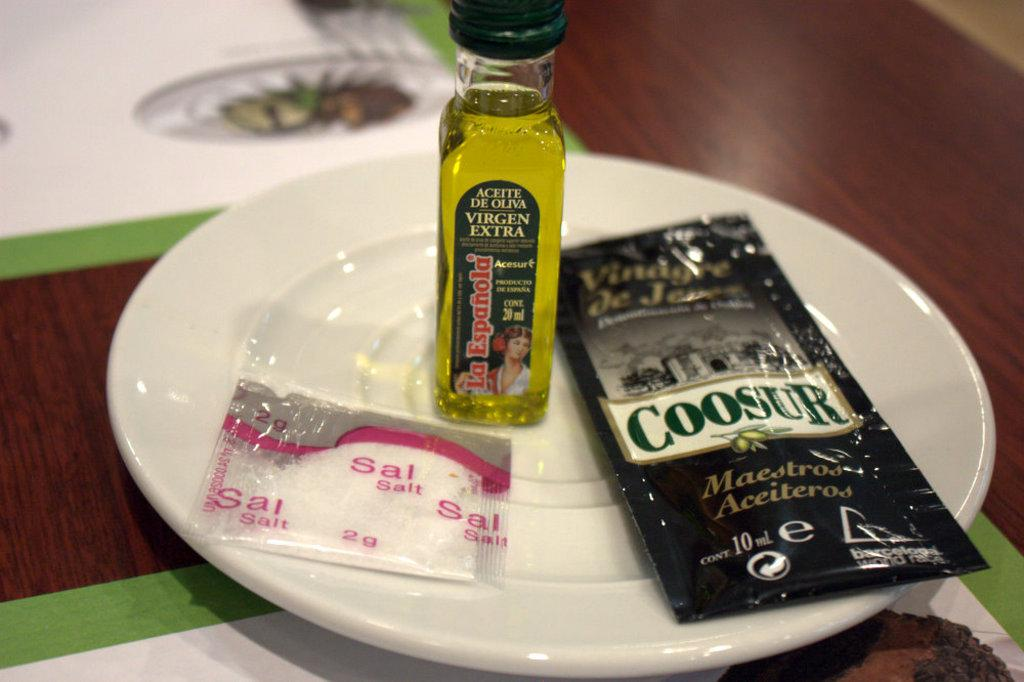What is on the white plate in the image? There is an oil bottle and salt on the white plate in the image. What is covering the items on the white plate? There is a black plastic cover on the white plate. Where is the white plate located? The plate is on a table. What is present on the table to protect it from heat or spills? There are mats on the table. How many boys are shown in the image? There are no boys present in the image. What is the mom doing in the image? There is no mom present in the image. 